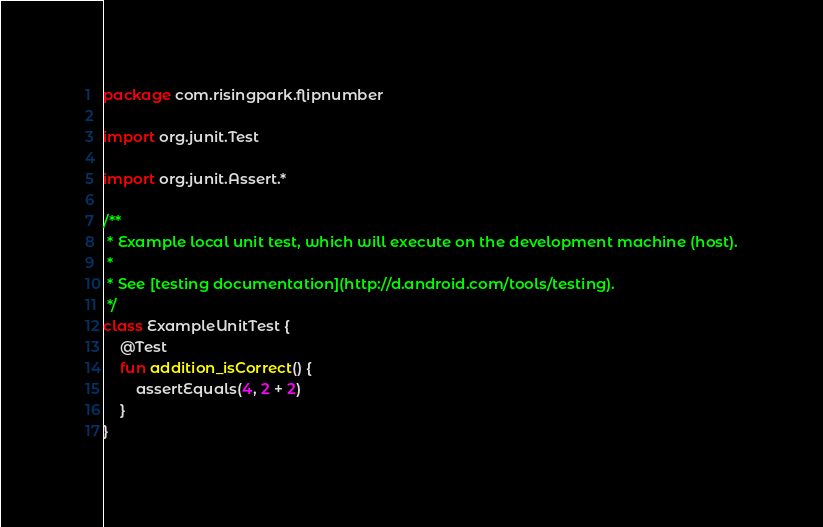Convert code to text. <code><loc_0><loc_0><loc_500><loc_500><_Kotlin_>package com.risingpark.flipnumber

import org.junit.Test

import org.junit.Assert.*

/**
 * Example local unit test, which will execute on the development machine (host).
 *
 * See [testing documentation](http://d.android.com/tools/testing).
 */
class ExampleUnitTest {
    @Test
    fun addition_isCorrect() {
        assertEquals(4, 2 + 2)
    }
}
</code> 